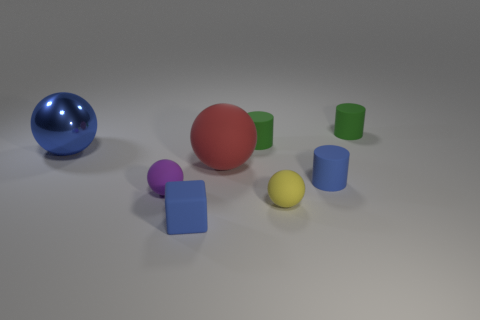How many other things are there of the same material as the red ball?
Your answer should be compact. 6. What number of rubber things are either blue things or cyan balls?
Your answer should be compact. 2. Is the number of blue metallic things less than the number of purple shiny cylinders?
Offer a very short reply. No. Do the purple object and the blue object that is in front of the purple matte object have the same size?
Provide a short and direct response. Yes. How big is the red matte thing?
Keep it short and to the point. Large. Are there fewer yellow spheres that are to the right of the yellow thing than big brown blocks?
Your response must be concise. No. Do the blue block and the purple rubber ball have the same size?
Offer a very short reply. Yes. There is a tiny block that is the same material as the red ball; what color is it?
Offer a terse response. Blue. Is the number of tiny rubber blocks that are to the left of the metal ball less than the number of tiny things behind the blue cylinder?
Ensure brevity in your answer.  Yes. What number of tiny cylinders are the same color as the shiny thing?
Your answer should be compact. 1. 